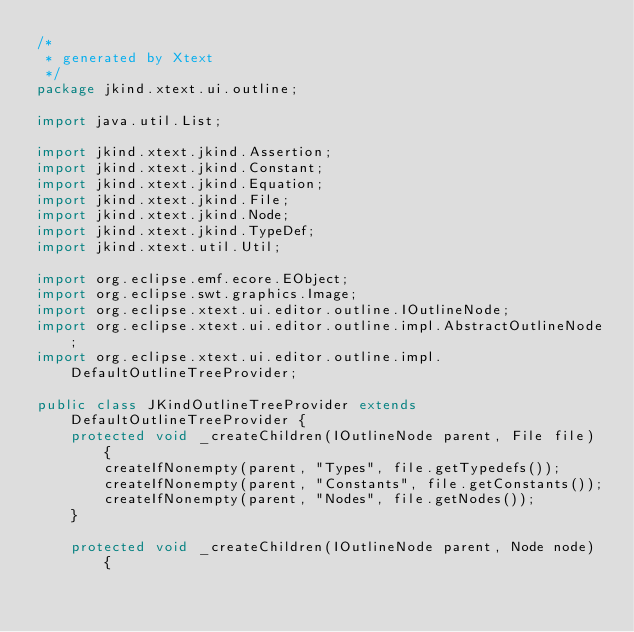Convert code to text. <code><loc_0><loc_0><loc_500><loc_500><_Java_>/*
 * generated by Xtext
 */
package jkind.xtext.ui.outline;

import java.util.List;

import jkind.xtext.jkind.Assertion;
import jkind.xtext.jkind.Constant;
import jkind.xtext.jkind.Equation;
import jkind.xtext.jkind.File;
import jkind.xtext.jkind.Node;
import jkind.xtext.jkind.TypeDef;
import jkind.xtext.util.Util;

import org.eclipse.emf.ecore.EObject;
import org.eclipse.swt.graphics.Image;
import org.eclipse.xtext.ui.editor.outline.IOutlineNode;
import org.eclipse.xtext.ui.editor.outline.impl.AbstractOutlineNode;
import org.eclipse.xtext.ui.editor.outline.impl.DefaultOutlineTreeProvider;

public class JKindOutlineTreeProvider extends DefaultOutlineTreeProvider {
	protected void _createChildren(IOutlineNode parent, File file) {
		createIfNonempty(parent, "Types", file.getTypedefs());
		createIfNonempty(parent, "Constants", file.getConstants());
		createIfNonempty(parent, "Nodes", file.getNodes());
	}

	protected void _createChildren(IOutlineNode parent, Node node) {</code> 